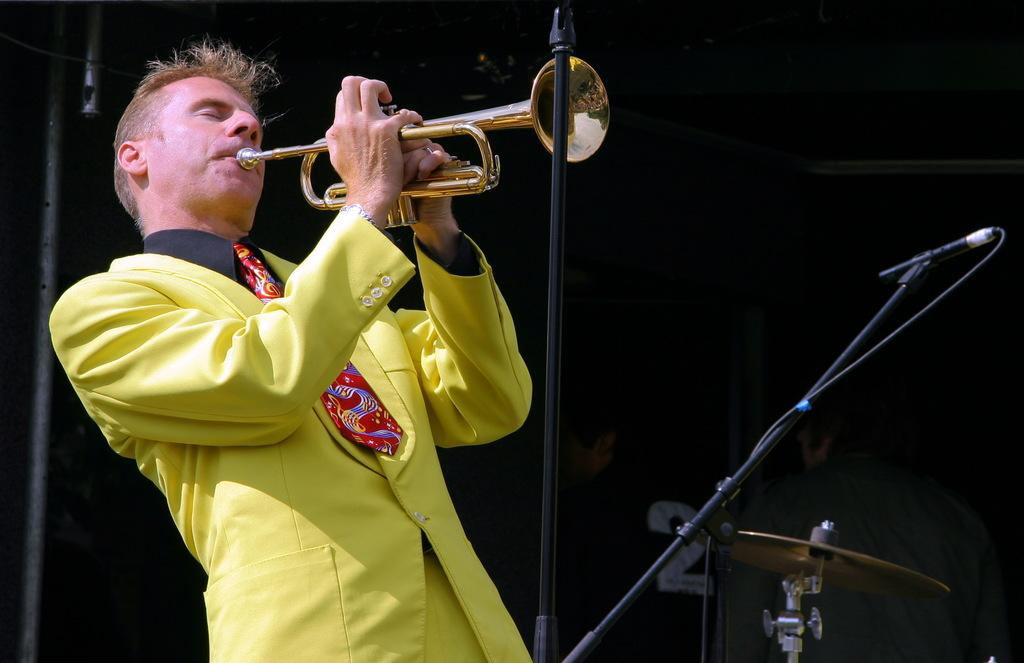What is the main subject of the image? The main subject of the image is a man. What is the man doing in the image? The man is standing and playing a trumpet. What other objects are present in the image? There is a microphone and a cymbal in the image. What can be observed about the background of the image? The background of the image is dark. What type of yarn is the man using to play the trumpet in the image? There is no yarn present in the image, and the man is playing a trumpet, which does not require yarn. 